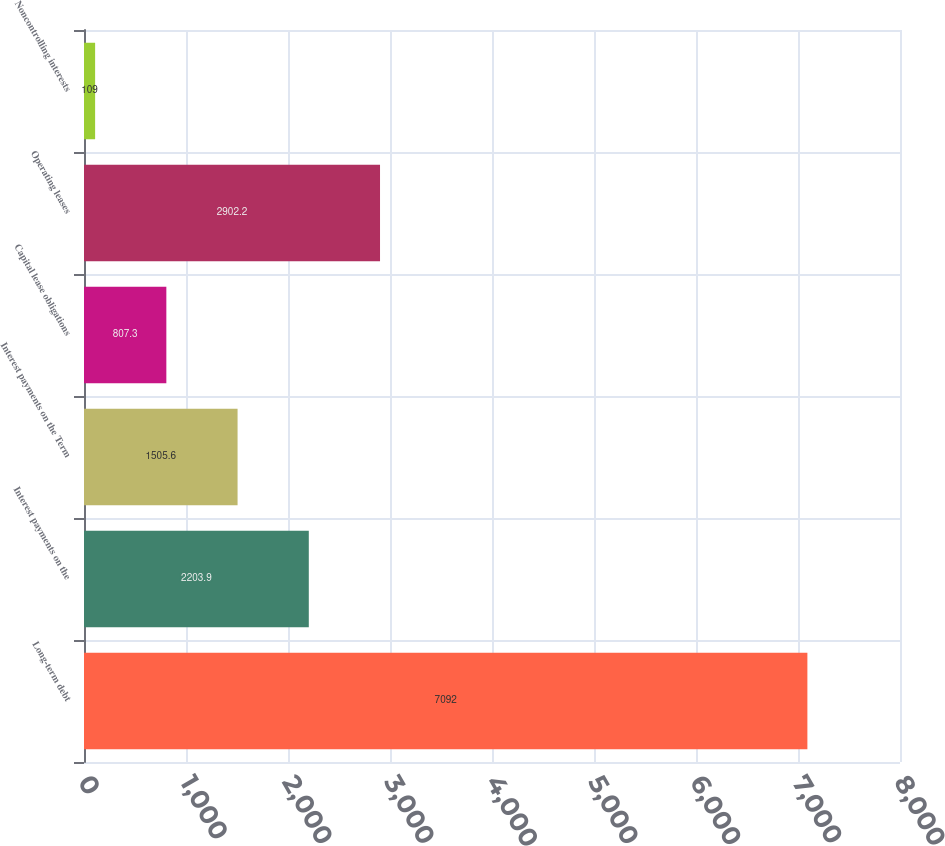Convert chart to OTSL. <chart><loc_0><loc_0><loc_500><loc_500><bar_chart><fcel>Long-term debt<fcel>Interest payments on the<fcel>Interest payments on the Term<fcel>Capital lease obligations<fcel>Operating leases<fcel>Noncontrolling interests<nl><fcel>7092<fcel>2203.9<fcel>1505.6<fcel>807.3<fcel>2902.2<fcel>109<nl></chart> 